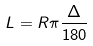Convert formula to latex. <formula><loc_0><loc_0><loc_500><loc_500>L = R \pi \frac { \Delta } { 1 8 0 }</formula> 